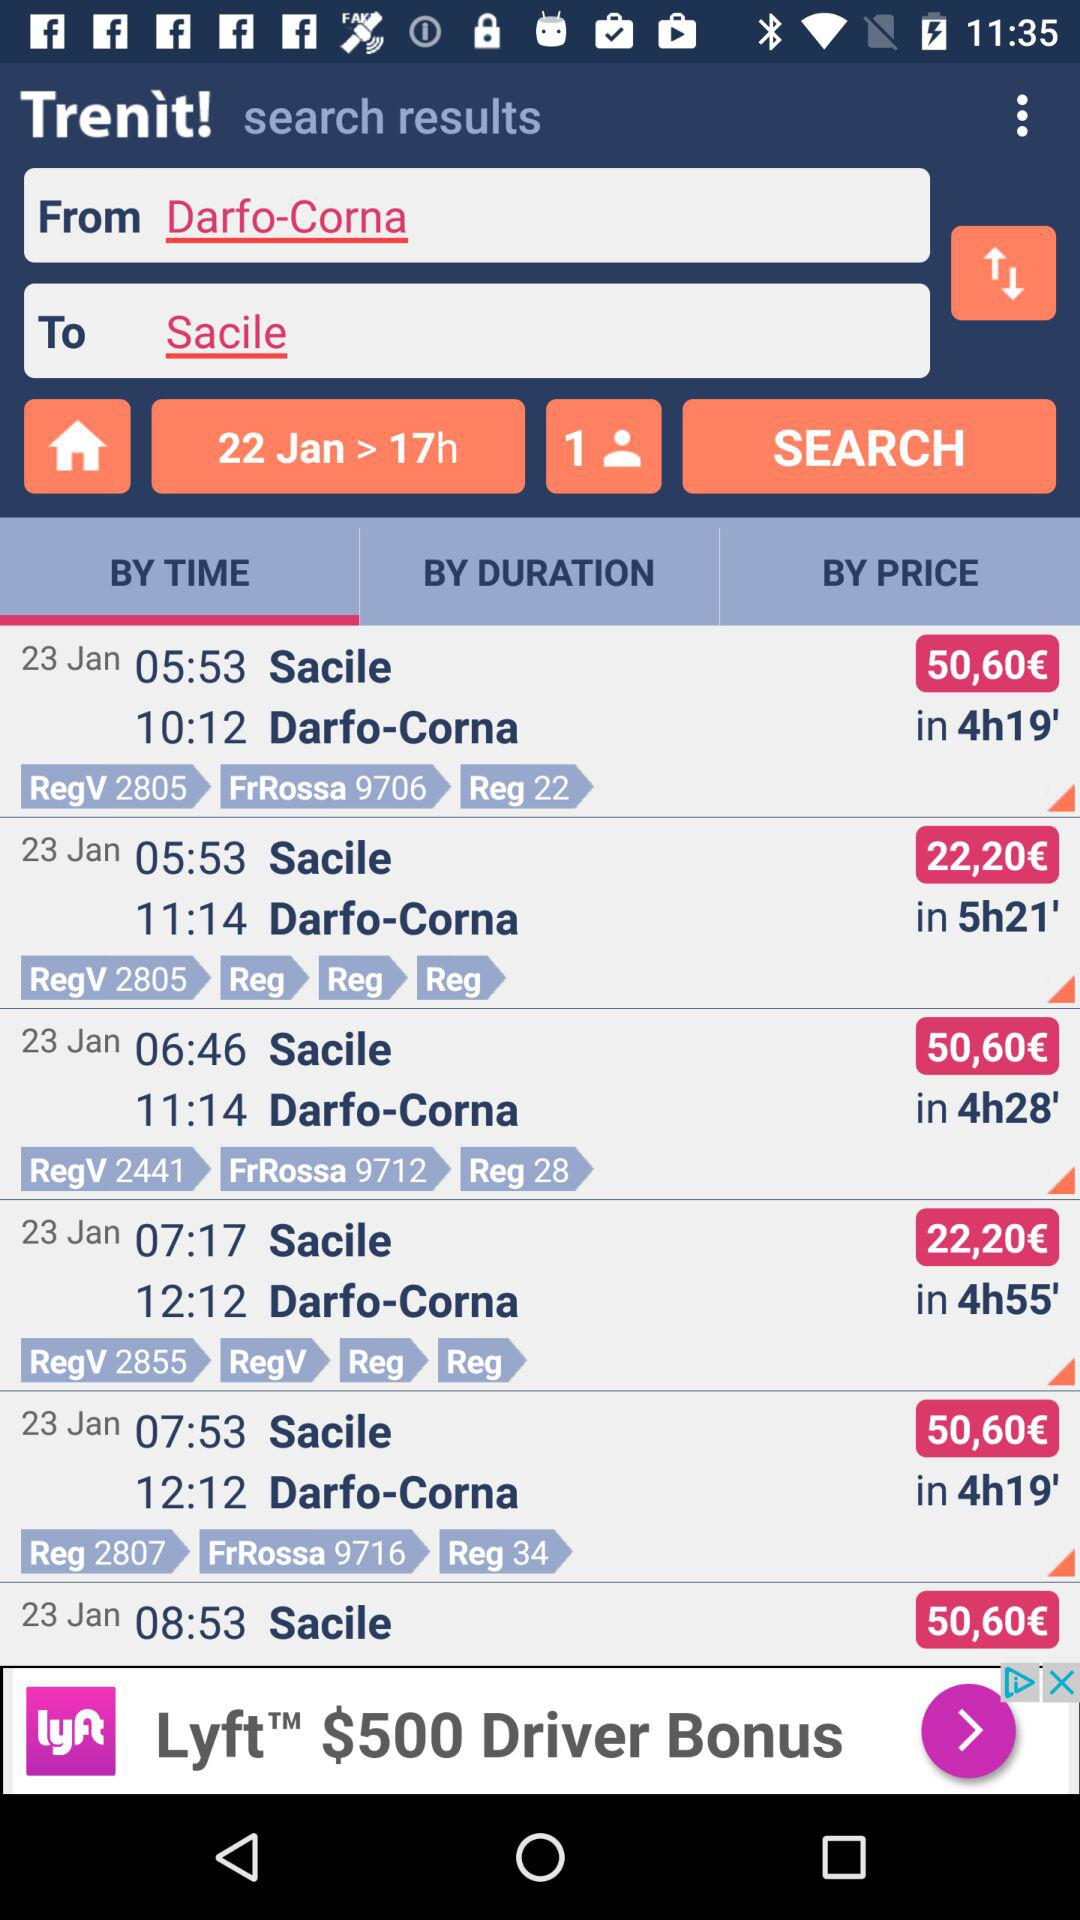What is the destination place? The destination place is Sacile. 